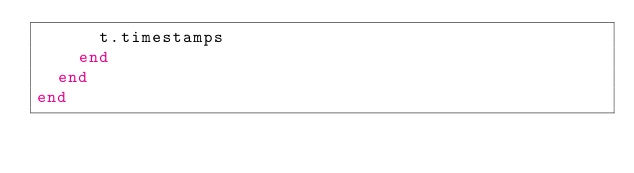<code> <loc_0><loc_0><loc_500><loc_500><_Ruby_>      t.timestamps
    end
  end
end
</code> 